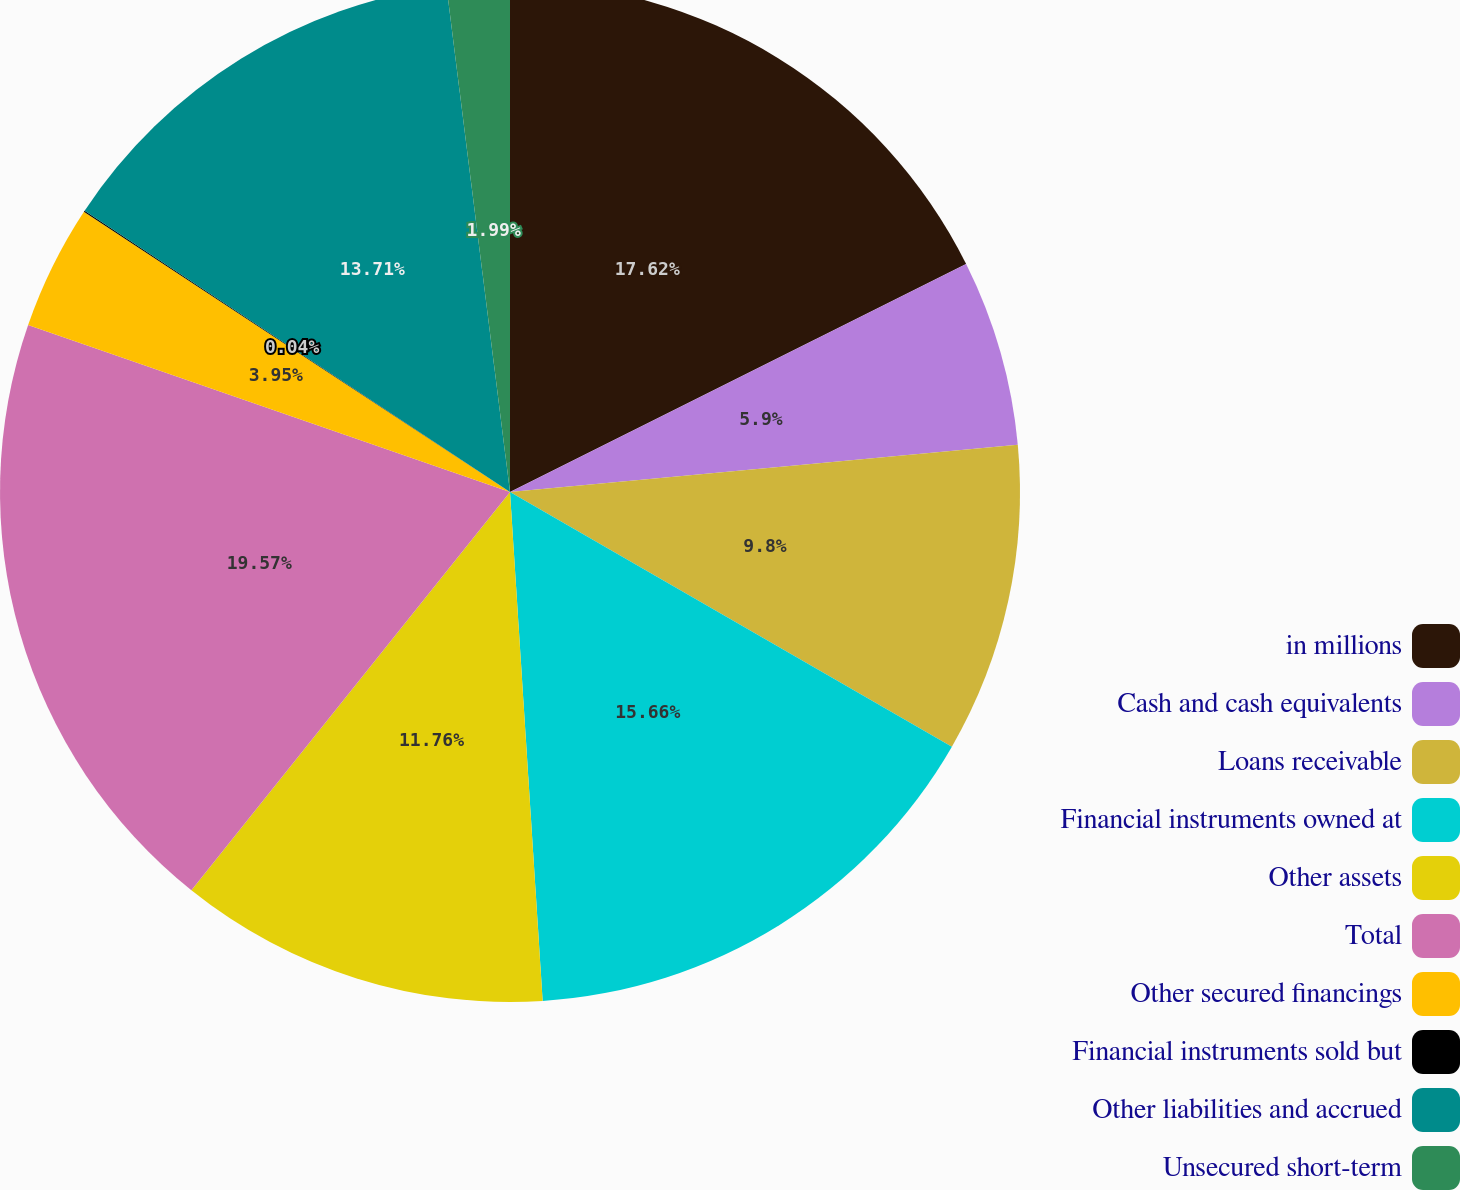<chart> <loc_0><loc_0><loc_500><loc_500><pie_chart><fcel>in millions<fcel>Cash and cash equivalents<fcel>Loans receivable<fcel>Financial instruments owned at<fcel>Other assets<fcel>Total<fcel>Other secured financings<fcel>Financial instruments sold but<fcel>Other liabilities and accrued<fcel>Unsecured short-term<nl><fcel>17.62%<fcel>5.9%<fcel>9.8%<fcel>15.66%<fcel>11.76%<fcel>19.57%<fcel>3.95%<fcel>0.04%<fcel>13.71%<fcel>1.99%<nl></chart> 